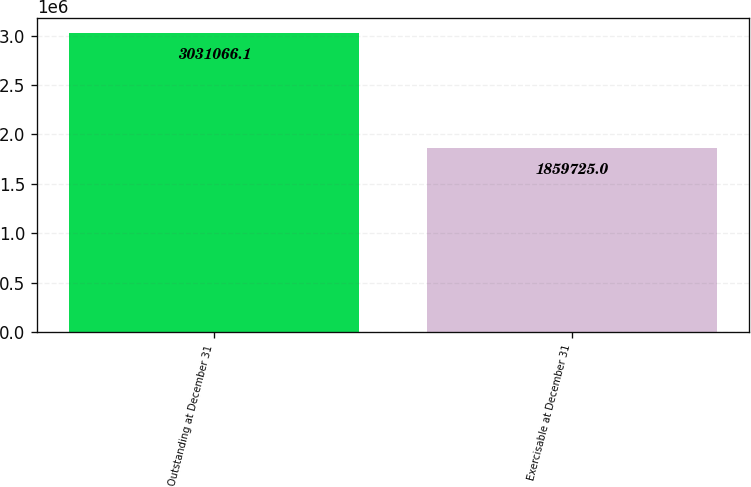Convert chart. <chart><loc_0><loc_0><loc_500><loc_500><bar_chart><fcel>Outstanding at December 31<fcel>Exercisable at December 31<nl><fcel>3.03107e+06<fcel>1.85972e+06<nl></chart> 